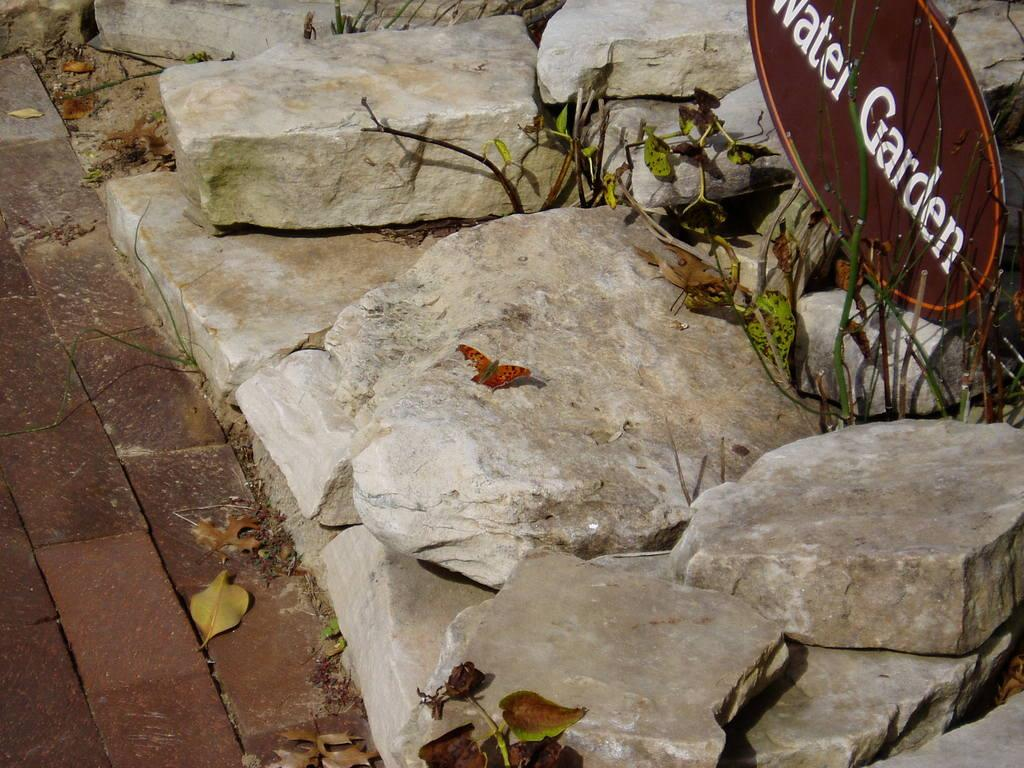What is on the rock in the image? There is a butterfly on a rock in the image. What type of object is brown in the image? There is a brown board in the image. What type of vegetation is present in the image? There are leaves in the image. What type of natural formation is present in the image? There are rocks in the image. What is the rate of the volcano's eruption in the image? There is no volcano present in the image, so it is not possible to determine the rate of its eruption. 